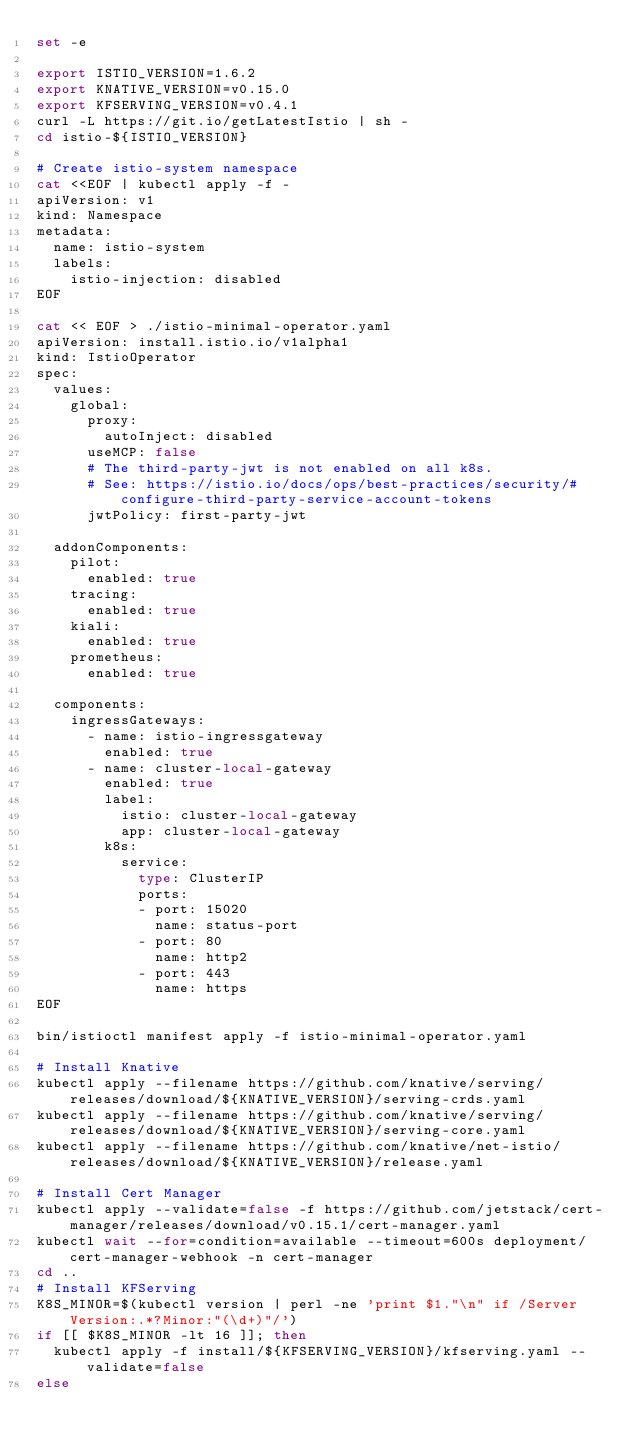Convert code to text. <code><loc_0><loc_0><loc_500><loc_500><_Bash_>set -e

export ISTIO_VERSION=1.6.2
export KNATIVE_VERSION=v0.15.0
export KFSERVING_VERSION=v0.4.1
curl -L https://git.io/getLatestIstio | sh -
cd istio-${ISTIO_VERSION}

# Create istio-system namespace
cat <<EOF | kubectl apply -f -
apiVersion: v1
kind: Namespace
metadata:
  name: istio-system
  labels:
    istio-injection: disabled
EOF

cat << EOF > ./istio-minimal-operator.yaml
apiVersion: install.istio.io/v1alpha1
kind: IstioOperator
spec:
  values:
    global:
      proxy:
        autoInject: disabled
      useMCP: false
      # The third-party-jwt is not enabled on all k8s.
      # See: https://istio.io/docs/ops/best-practices/security/#configure-third-party-service-account-tokens
      jwtPolicy: first-party-jwt

  addonComponents:
    pilot:
      enabled: true
    tracing:
      enabled: true
    kiali:
      enabled: true
    prometheus:
      enabled: true

  components:
    ingressGateways:
      - name: istio-ingressgateway
        enabled: true
      - name: cluster-local-gateway
        enabled: true
        label:
          istio: cluster-local-gateway
          app: cluster-local-gateway
        k8s:
          service:
            type: ClusterIP
            ports:
            - port: 15020
              name: status-port
            - port: 80
              name: http2
            - port: 443
              name: https
EOF

bin/istioctl manifest apply -f istio-minimal-operator.yaml

# Install Knative
kubectl apply --filename https://github.com/knative/serving/releases/download/${KNATIVE_VERSION}/serving-crds.yaml
kubectl apply --filename https://github.com/knative/serving/releases/download/${KNATIVE_VERSION}/serving-core.yaml
kubectl apply --filename https://github.com/knative/net-istio/releases/download/${KNATIVE_VERSION}/release.yaml

# Install Cert Manager
kubectl apply --validate=false -f https://github.com/jetstack/cert-manager/releases/download/v0.15.1/cert-manager.yaml
kubectl wait --for=condition=available --timeout=600s deployment/cert-manager-webhook -n cert-manager
cd ..
# Install KFServing
K8S_MINOR=$(kubectl version | perl -ne 'print $1."\n" if /Server Version:.*?Minor:"(\d+)"/')
if [[ $K8S_MINOR -lt 16 ]]; then
  kubectl apply -f install/${KFSERVING_VERSION}/kfserving.yaml --validate=false
else</code> 